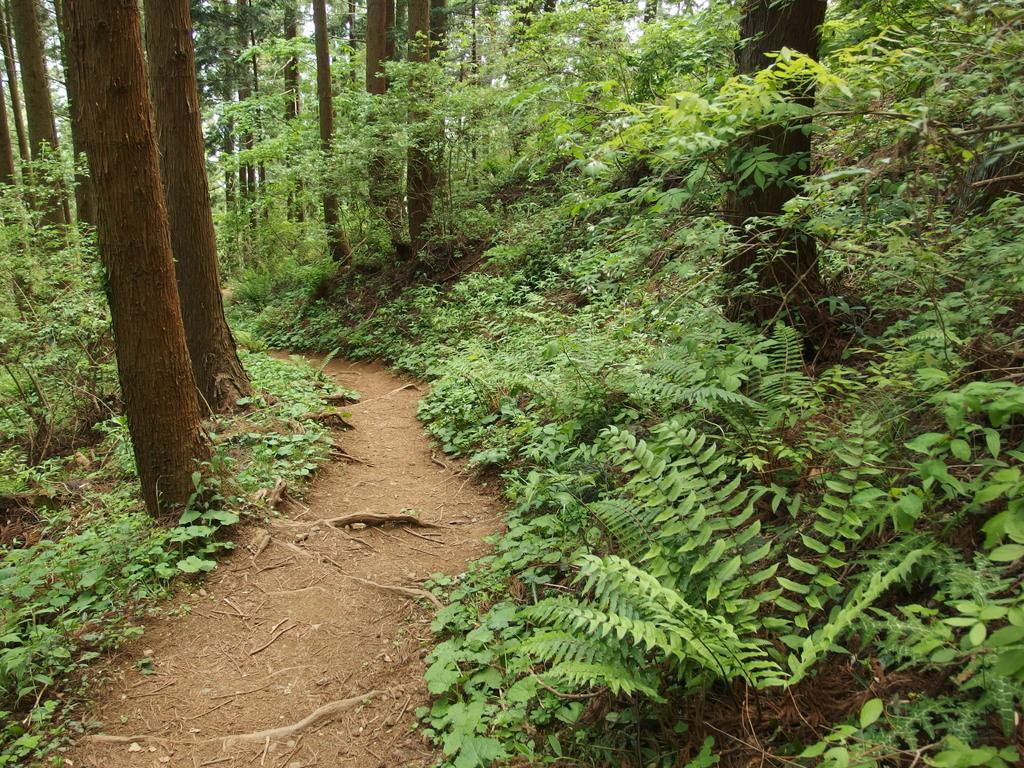What can be seen in the image that people might walk on? There is a path in the image that people might walk on. What type of vegetation is present in the image? There are plants in the image. What can be seen in the distance in the image? There are trees visible in the background of the image. What verse is being recited by the plants in the image? There are no verses or recitations present in the image; it features a path, plants, and trees. How long does it take for the minute hand to move in the image? There is no clock or time-related element present in the image, so it is not possible to determine the movement of a minute hand. 